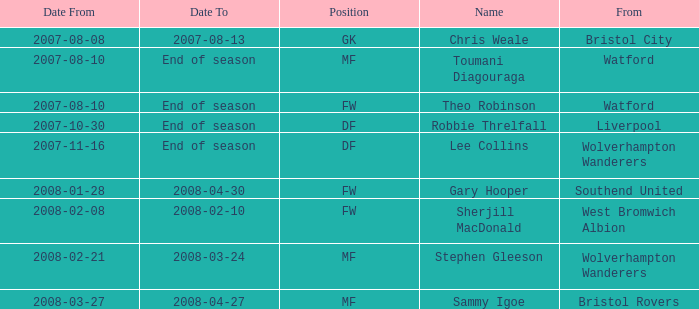On which date did toumani diagouraga, an mf position player, begin? 2007-08-10. 